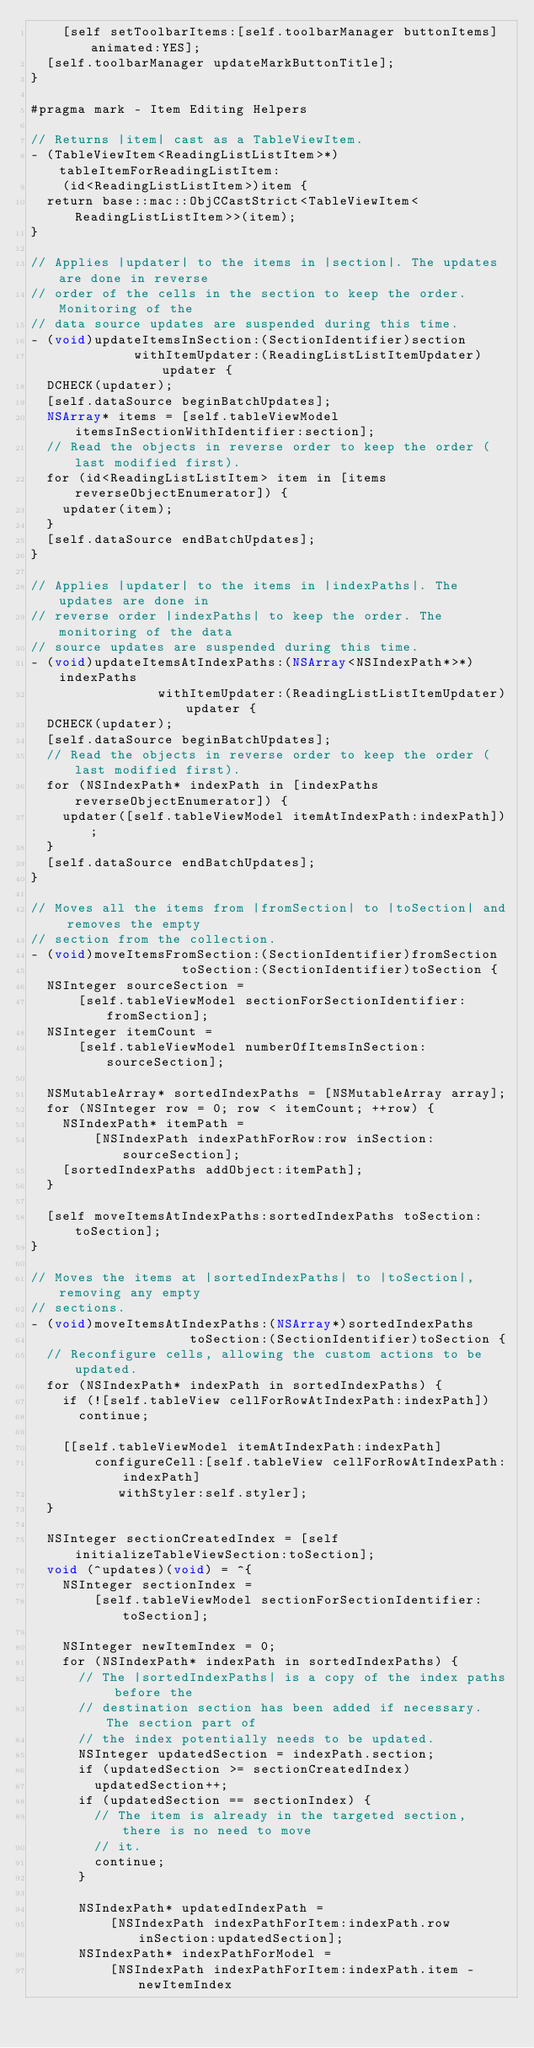Convert code to text. <code><loc_0><loc_0><loc_500><loc_500><_ObjectiveC_>    [self setToolbarItems:[self.toolbarManager buttonItems] animated:YES];
  [self.toolbarManager updateMarkButtonTitle];
}

#pragma mark - Item Editing Helpers

// Returns |item| cast as a TableViewItem.
- (TableViewItem<ReadingListListItem>*)tableItemForReadingListItem:
    (id<ReadingListListItem>)item {
  return base::mac::ObjCCastStrict<TableViewItem<ReadingListListItem>>(item);
}

// Applies |updater| to the items in |section|. The updates are done in reverse
// order of the cells in the section to keep the order. Monitoring of the
// data source updates are suspended during this time.
- (void)updateItemsInSection:(SectionIdentifier)section
             withItemUpdater:(ReadingListListItemUpdater)updater {
  DCHECK(updater);
  [self.dataSource beginBatchUpdates];
  NSArray* items = [self.tableViewModel itemsInSectionWithIdentifier:section];
  // Read the objects in reverse order to keep the order (last modified first).
  for (id<ReadingListListItem> item in [items reverseObjectEnumerator]) {
    updater(item);
  }
  [self.dataSource endBatchUpdates];
}

// Applies |updater| to the items in |indexPaths|. The updates are done in
// reverse order |indexPaths| to keep the order. The monitoring of the data
// source updates are suspended during this time.
- (void)updateItemsAtIndexPaths:(NSArray<NSIndexPath*>*)indexPaths
                withItemUpdater:(ReadingListListItemUpdater)updater {
  DCHECK(updater);
  [self.dataSource beginBatchUpdates];
  // Read the objects in reverse order to keep the order (last modified first).
  for (NSIndexPath* indexPath in [indexPaths reverseObjectEnumerator]) {
    updater([self.tableViewModel itemAtIndexPath:indexPath]);
  }
  [self.dataSource endBatchUpdates];
}

// Moves all the items from |fromSection| to |toSection| and removes the empty
// section from the collection.
- (void)moveItemsFromSection:(SectionIdentifier)fromSection
                   toSection:(SectionIdentifier)toSection {
  NSInteger sourceSection =
      [self.tableViewModel sectionForSectionIdentifier:fromSection];
  NSInteger itemCount =
      [self.tableViewModel numberOfItemsInSection:sourceSection];

  NSMutableArray* sortedIndexPaths = [NSMutableArray array];
  for (NSInteger row = 0; row < itemCount; ++row) {
    NSIndexPath* itemPath =
        [NSIndexPath indexPathForRow:row inSection:sourceSection];
    [sortedIndexPaths addObject:itemPath];
  }

  [self moveItemsAtIndexPaths:sortedIndexPaths toSection:toSection];
}

// Moves the items at |sortedIndexPaths| to |toSection|, removing any empty
// sections.
- (void)moveItemsAtIndexPaths:(NSArray*)sortedIndexPaths
                    toSection:(SectionIdentifier)toSection {
  // Reconfigure cells, allowing the custom actions to be updated.
  for (NSIndexPath* indexPath in sortedIndexPaths) {
    if (![self.tableView cellForRowAtIndexPath:indexPath])
      continue;

    [[self.tableViewModel itemAtIndexPath:indexPath]
        configureCell:[self.tableView cellForRowAtIndexPath:indexPath]
           withStyler:self.styler];
  }

  NSInteger sectionCreatedIndex = [self initializeTableViewSection:toSection];
  void (^updates)(void) = ^{
    NSInteger sectionIndex =
        [self.tableViewModel sectionForSectionIdentifier:toSection];

    NSInteger newItemIndex = 0;
    for (NSIndexPath* indexPath in sortedIndexPaths) {
      // The |sortedIndexPaths| is a copy of the index paths before the
      // destination section has been added if necessary. The section part of
      // the index potentially needs to be updated.
      NSInteger updatedSection = indexPath.section;
      if (updatedSection >= sectionCreatedIndex)
        updatedSection++;
      if (updatedSection == sectionIndex) {
        // The item is already in the targeted section, there is no need to move
        // it.
        continue;
      }

      NSIndexPath* updatedIndexPath =
          [NSIndexPath indexPathForItem:indexPath.row inSection:updatedSection];
      NSIndexPath* indexPathForModel =
          [NSIndexPath indexPathForItem:indexPath.item - newItemIndex</code> 